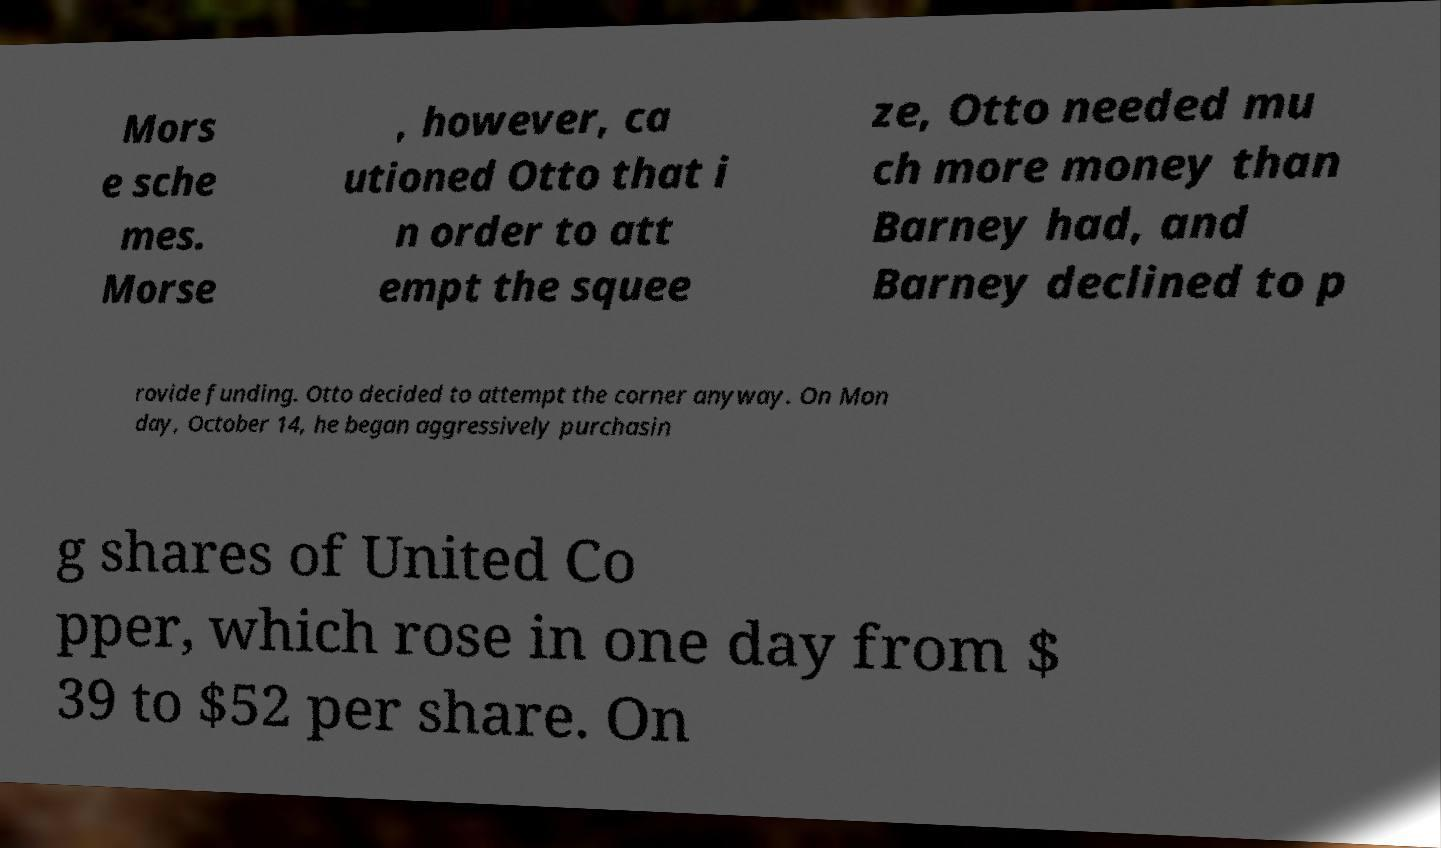I need the written content from this picture converted into text. Can you do that? Mors e sche mes. Morse , however, ca utioned Otto that i n order to att empt the squee ze, Otto needed mu ch more money than Barney had, and Barney declined to p rovide funding. Otto decided to attempt the corner anyway. On Mon day, October 14, he began aggressively purchasin g shares of United Co pper, which rose in one day from $ 39 to $52 per share. On 